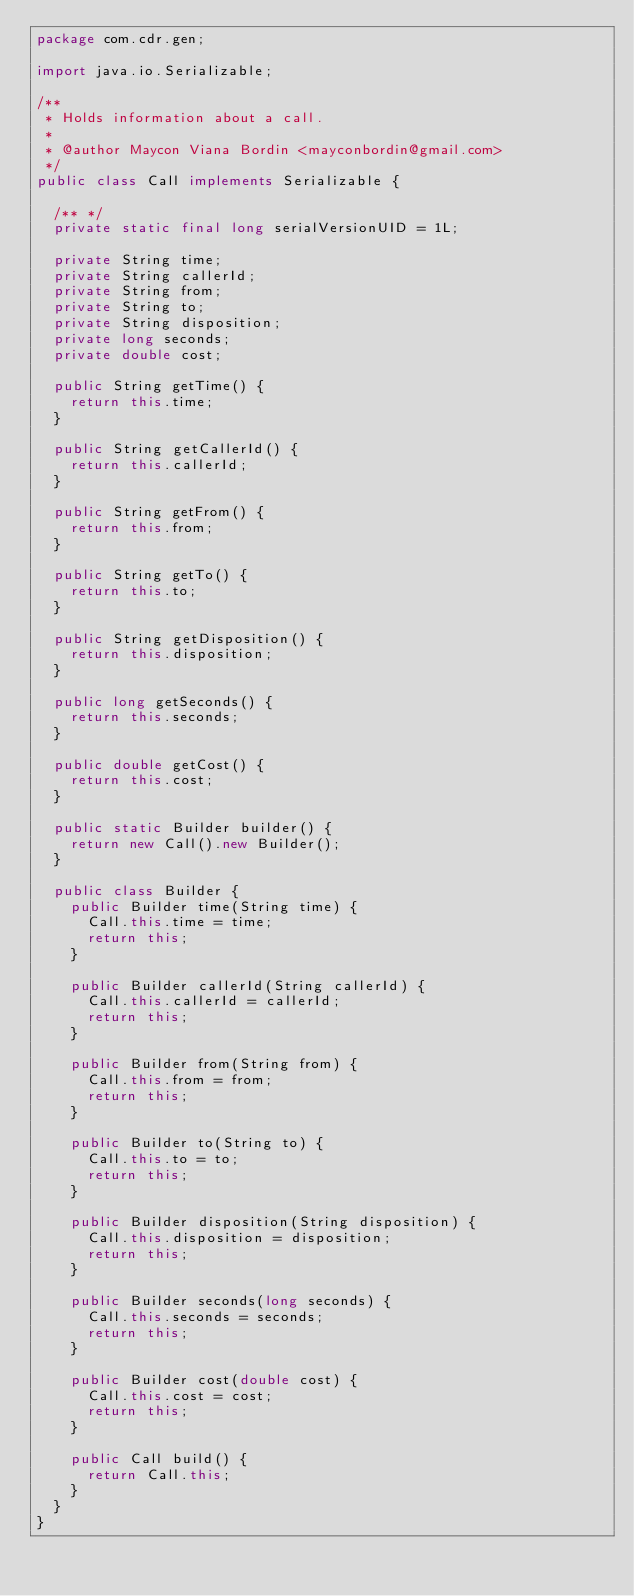Convert code to text. <code><loc_0><loc_0><loc_500><loc_500><_Java_>package com.cdr.gen;

import java.io.Serializable;

/**
 * Holds information about a call.
 *
 * @author Maycon Viana Bordin <mayconbordin@gmail.com>
 */
public class Call implements Serializable {

  /** */
  private static final long serialVersionUID = 1L;

  private String time;
  private String callerId;
  private String from;
  private String to;
  private String disposition;
  private long seconds;
  private double cost;

  public String getTime() {
    return this.time;
  }

  public String getCallerId() {
    return this.callerId;
  }

  public String getFrom() {
    return this.from;
  }

  public String getTo() {
    return this.to;
  }

  public String getDisposition() {
    return this.disposition;
  }

  public long getSeconds() {
    return this.seconds;
  }

  public double getCost() {
    return this.cost;
  }

  public static Builder builder() {
    return new Call().new Builder();
  }

  public class Builder {
    public Builder time(String time) {
      Call.this.time = time;
      return this;
    }

    public Builder callerId(String callerId) {
      Call.this.callerId = callerId;
      return this;
    }

    public Builder from(String from) {
      Call.this.from = from;
      return this;
    }

    public Builder to(String to) {
      Call.this.to = to;
      return this;
    }

    public Builder disposition(String disposition) {
      Call.this.disposition = disposition;
      return this;
    }

    public Builder seconds(long seconds) {
      Call.this.seconds = seconds;
      return this;
    }

    public Builder cost(double cost) {
      Call.this.cost = cost;
      return this;
    }

    public Call build() {
      return Call.this;
    }
  }
}
</code> 